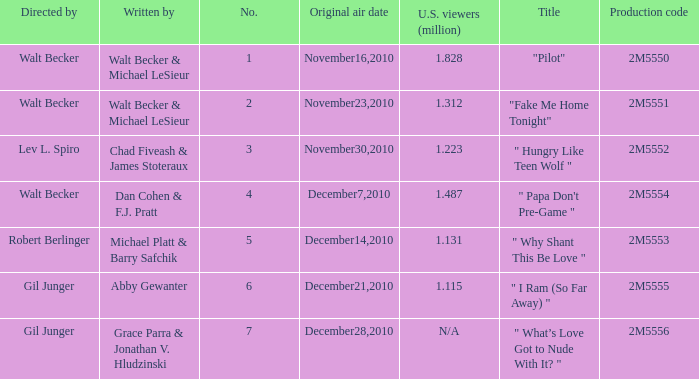How many million U.S. viewers saw "Fake Me Home Tonight"? 1.312. 